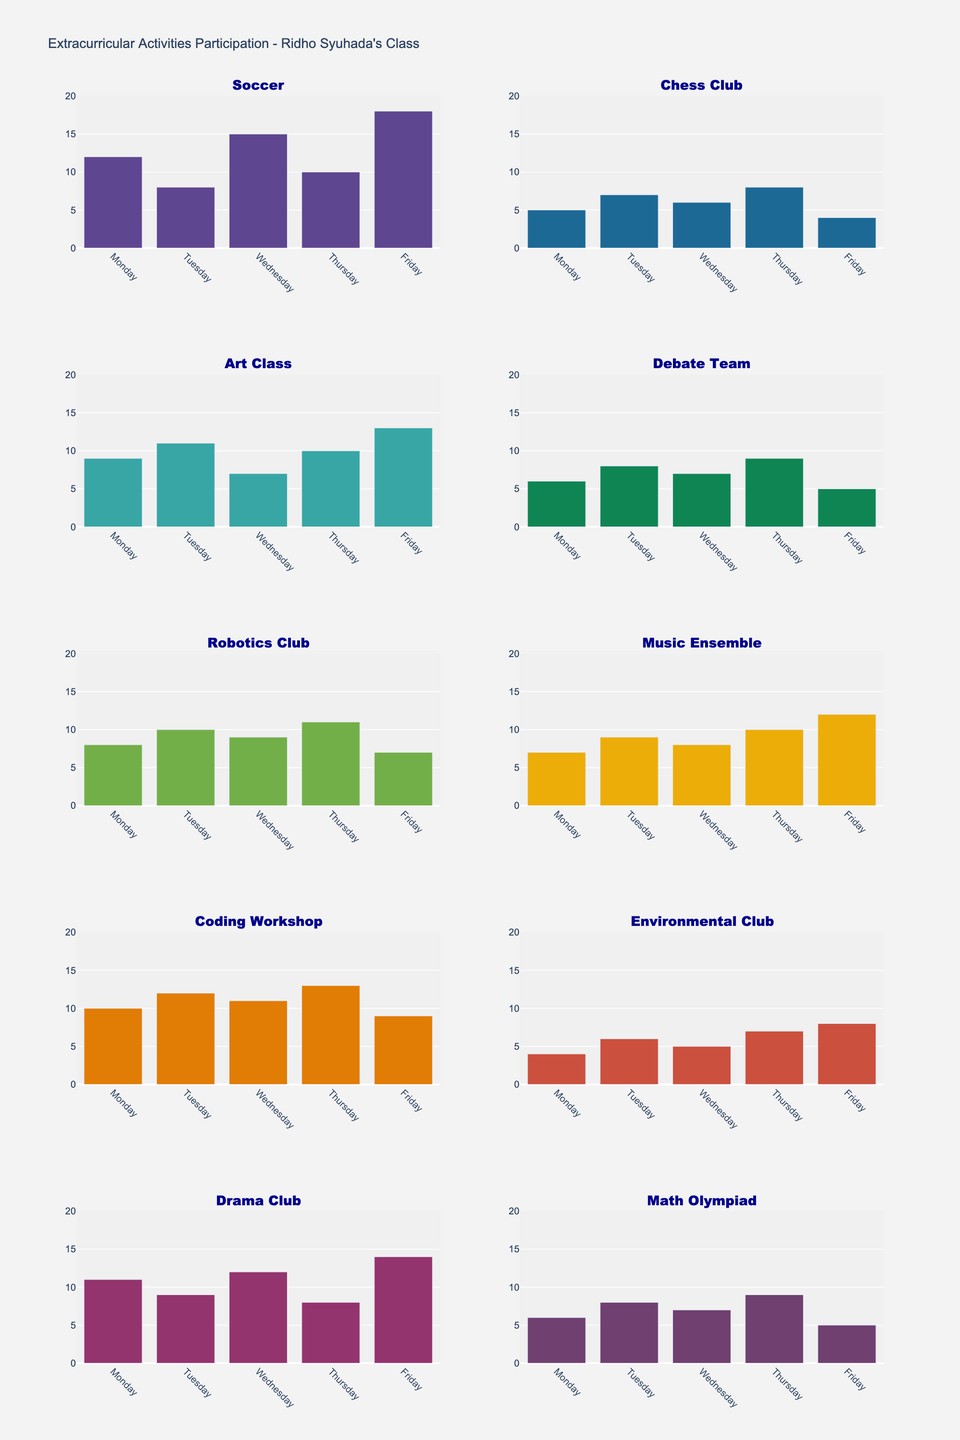Which activity has the highest participation on Friday? Look across all the subplots and identify the bar for Friday in each one. The activity with the tallest bar on Friday is the one with the highest participation.
Answer: Soccer Which day of the week has the lowest participation for Drama Club? In the Drama Club subplot, compare the heights of the bars for each day. The shortest bar represents the day with the lowest participation.
Answer: Thursday What is the average participation rate for Chess Club over the week? Add the number of participants for each day (5 + 7 + 6 + 8 + 4) to get a total of 30. Then, divide that by the number of days (5) to find the average.
Answer: 6 Is the participation rate of Robotics Club on Monday greater than or less than that of Music Ensemble on Monday? Look at the Monday bars for both the Robotics Club and Music Ensemble subplots. Compare their heights to determine which is greater.
Answer: Greater What is the total participation for the Debate Team over the week? Sum the number of participants for each day (6 + 8 + 7 + 9 + 5) to get the total.
Answer: 35 Which day had the highest total participation across all activities? Add the participation numbers for all activities on each day and compare the sums.
Answer: Friday Was Ridho Syuhada's class more involved in Coding Workshop on Thursday or Environmental Club on Friday? Compare the heights of the Thursday bar in the Coding Workshop subplot and the Friday bar in the Environmental Club subplot.
Answer: Coding Workshop on Thursday How much did the participation for Soccer fluctuate over the week? Identify the difference between the highest and lowest participation values for Soccer throughout the week (18 - 8).
Answer: 10 Which had a higher peak participation, the Art Class or the Drama Club? Compare the highest single-day participation number for both Art Class and Drama Club (13 vs 14).
Answer: Drama Club 